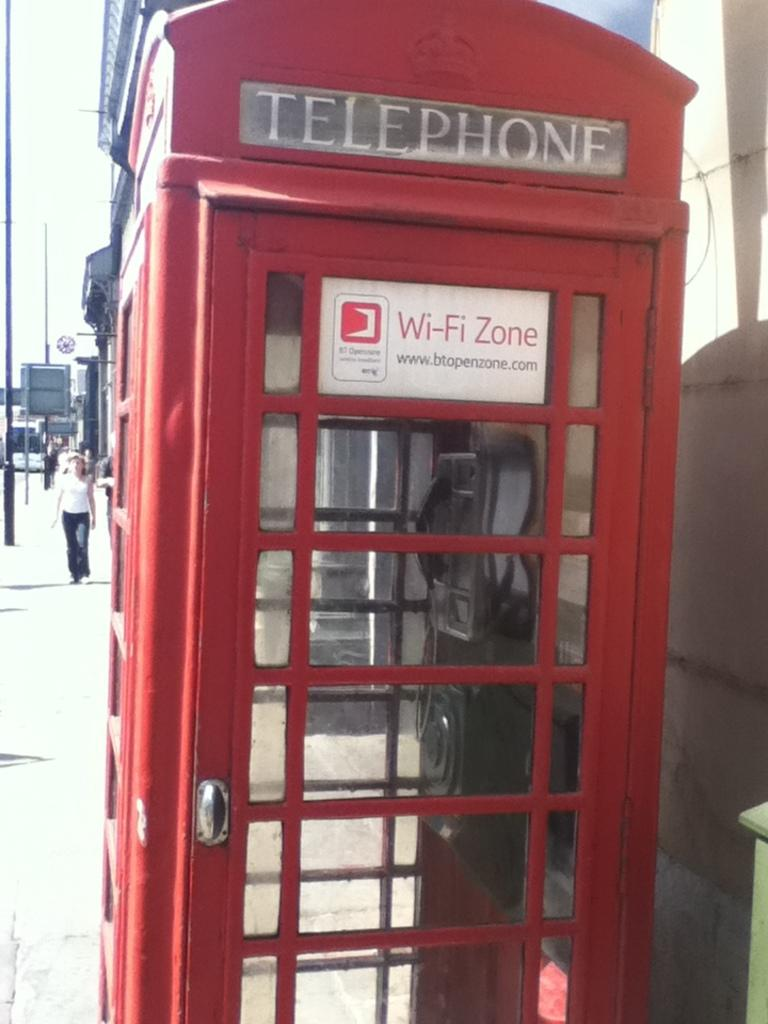<image>
Describe the image concisely. A red telephone box positioned on the side walk. 